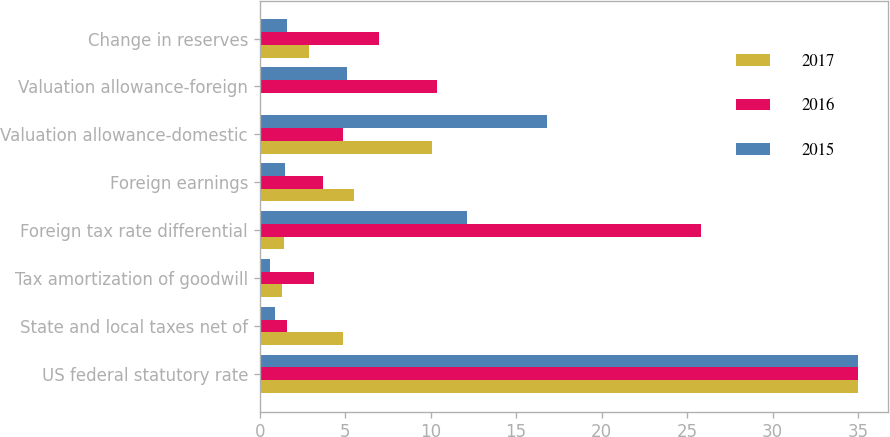Convert chart to OTSL. <chart><loc_0><loc_0><loc_500><loc_500><stacked_bar_chart><ecel><fcel>US federal statutory rate<fcel>State and local taxes net of<fcel>Tax amortization of goodwill<fcel>Foreign tax rate differential<fcel>Foreign earnings<fcel>Valuation allowance-domestic<fcel>Valuation allowance-foreign<fcel>Change in reserves<nl><fcel>2017<fcel>35<fcel>4.9<fcel>1.3<fcel>1.4<fcel>5.5<fcel>10.1<fcel>0.1<fcel>2.9<nl><fcel>2016<fcel>35<fcel>1.6<fcel>3.2<fcel>25.8<fcel>3.7<fcel>4.9<fcel>10.4<fcel>7<nl><fcel>2015<fcel>35<fcel>0.9<fcel>0.6<fcel>12.1<fcel>1.5<fcel>16.8<fcel>5.1<fcel>1.6<nl></chart> 